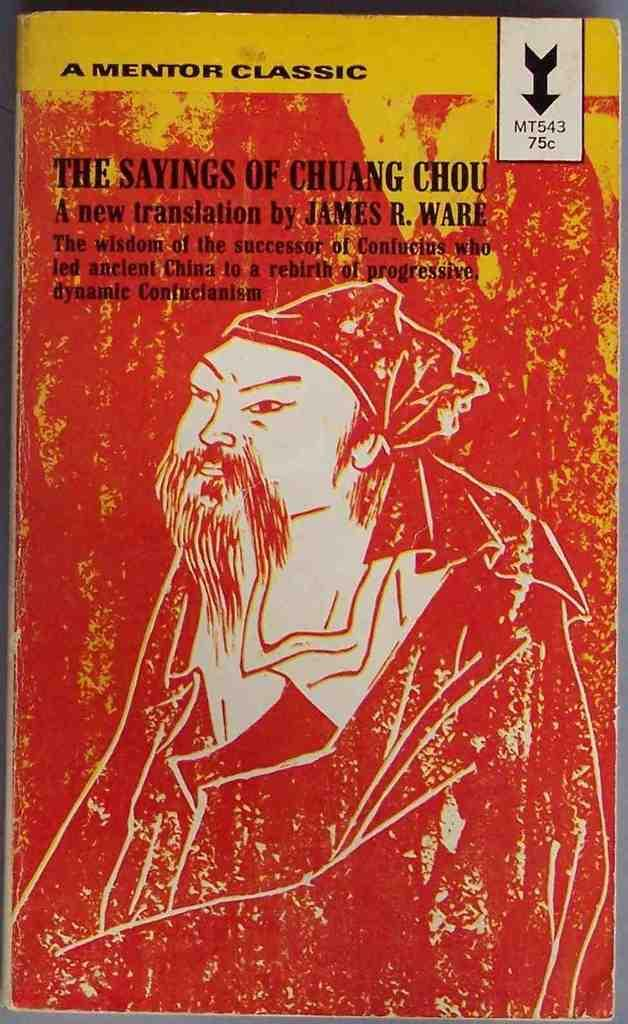<image>
Relay a brief, clear account of the picture shown. A Mentor Classic, the Sayings of Chuang Chou is translated by James Ware. 